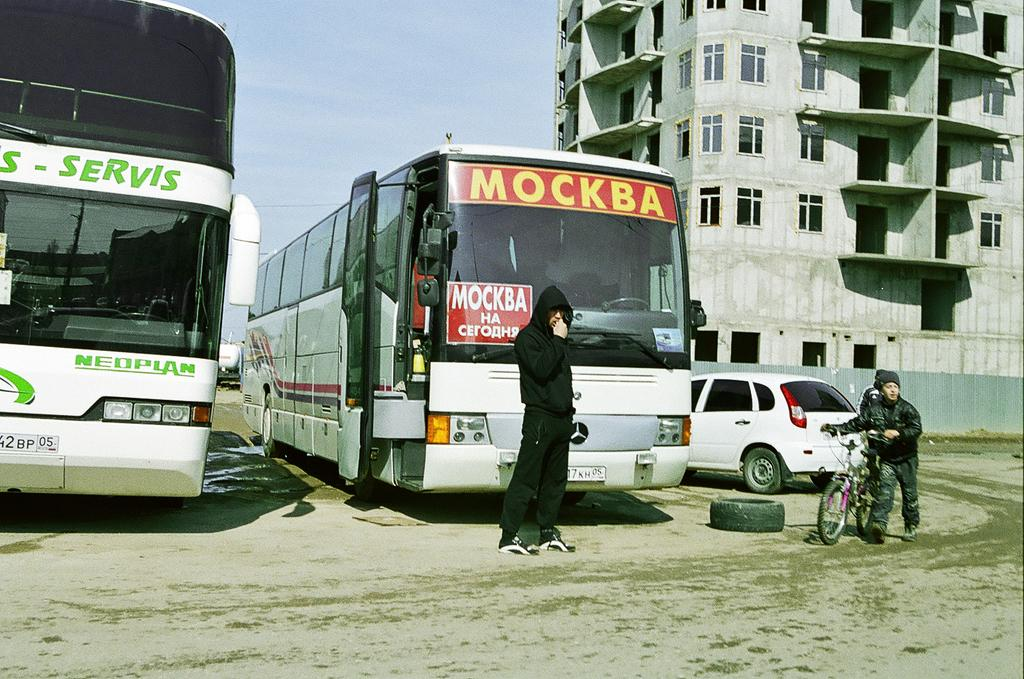<image>
Share a concise interpretation of the image provided. the word mockba that is on a bus 